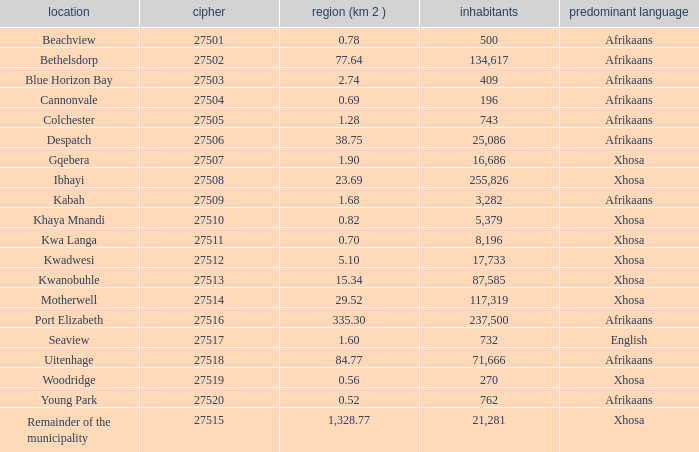What is the total code number for places with a population greater than 87,585? 4.0. 